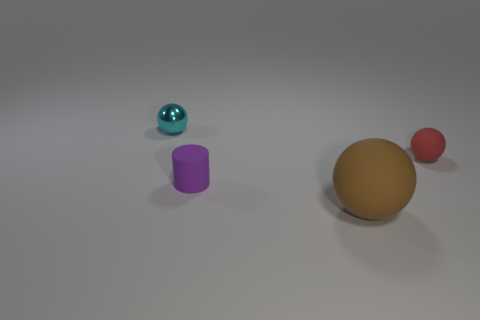Do the matte sphere that is in front of the purple object and the cylinder have the same size?
Keep it short and to the point. No. There is a rubber object that is right of the tiny purple rubber object and in front of the small red sphere; how big is it?
Your answer should be very brief. Large. What number of small metal balls are the same color as the tiny rubber cylinder?
Your response must be concise. 0. Are there the same number of brown rubber things left of the cyan sphere and metal things?
Keep it short and to the point. No. The tiny metal object has what color?
Offer a very short reply. Cyan. There is a brown sphere that is the same material as the red thing; what is its size?
Provide a succinct answer. Large. What color is the other sphere that is made of the same material as the large sphere?
Your response must be concise. Red. Is there a gray matte thing that has the same size as the cyan shiny thing?
Ensure brevity in your answer.  No. There is a tiny red thing that is the same shape as the small cyan object; what is its material?
Your answer should be very brief. Rubber. The red thing that is the same size as the cyan thing is what shape?
Offer a terse response. Sphere. 